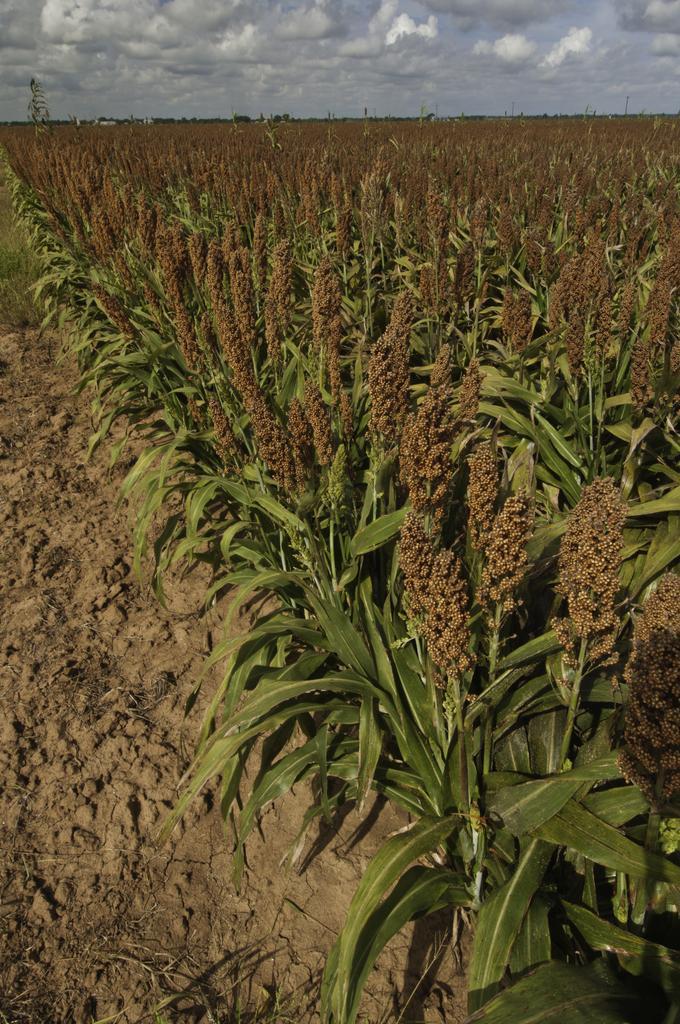Could you give a brief overview of what you see in this image? In this image I see the mud and I see number of plants and in the background I see the sky which is a bit cloudy. 